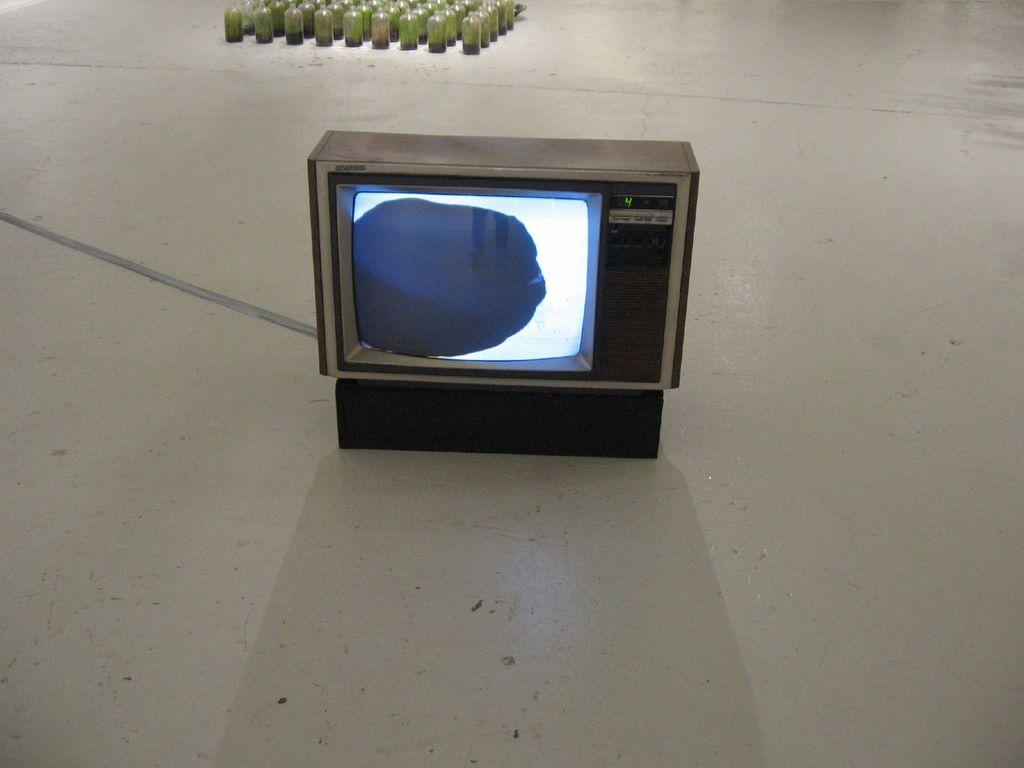What number is the channel?
Your response must be concise. 4. 